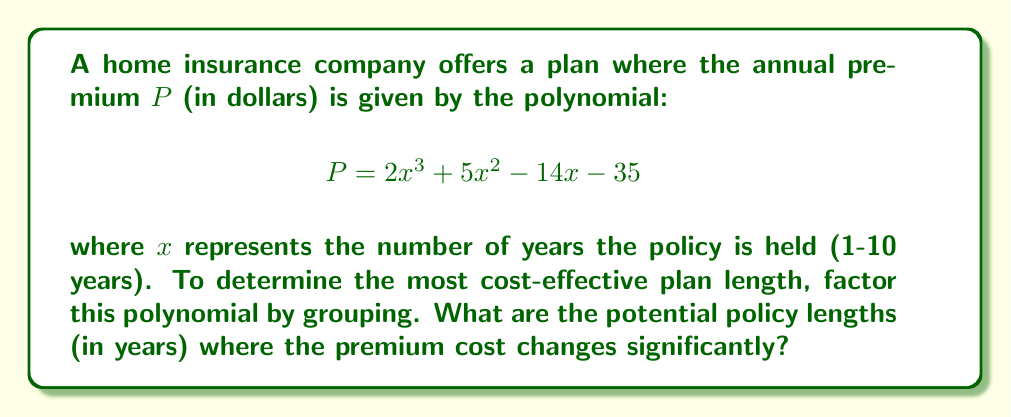Show me your answer to this math problem. To factor this polynomial by grouping, we'll follow these steps:

1) First, split the polynomial into two groups:
   $$(2x^3 + 5x^2) + (-14x - 35)$$

2) Factor out the greatest common factor (GCF) from each group:
   $$x^2(2x + 5) - 7(2x + 5)$$

3) Notice that $(2x + 5)$ is common to both terms. Factor this out:
   $$(2x + 5)(x^2 - 7)$$

4) The second factor $(x^2 - 7)$ can be further factored:
   $$(2x + 5)(x - \sqrt{7})(x + \sqrt{7})$$

5) Therefore, the fully factored polynomial is:
   $$P = (2x + 5)(x - \sqrt{7})(x + \sqrt{7})$$

The factors represent the points where the polynomial crosses the x-axis, which indicate significant changes in the premium cost:

- When $x = -\frac{5}{2} = -2.5$ (not relevant as policy length can't be negative)
- When $x = \sqrt{7} \approx 2.65$
- When $x = -\sqrt{7} \approx -2.65$ (not relevant as policy length can't be negative)

The relevant solution is $x \approx 2.65$ years, which rounds to 3 years.
Answer: The potential policy length where the premium cost changes significantly is approximately 3 years. 